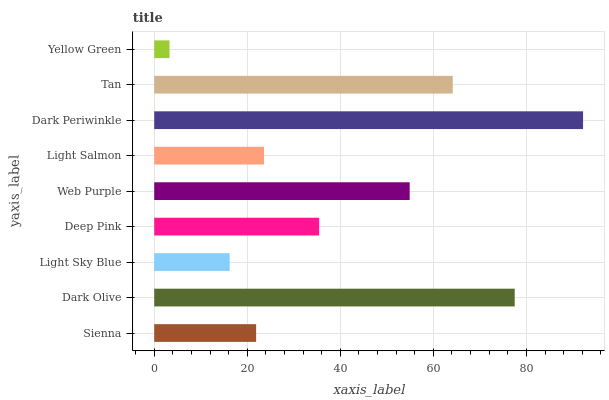Is Yellow Green the minimum?
Answer yes or no. Yes. Is Dark Periwinkle the maximum?
Answer yes or no. Yes. Is Dark Olive the minimum?
Answer yes or no. No. Is Dark Olive the maximum?
Answer yes or no. No. Is Dark Olive greater than Sienna?
Answer yes or no. Yes. Is Sienna less than Dark Olive?
Answer yes or no. Yes. Is Sienna greater than Dark Olive?
Answer yes or no. No. Is Dark Olive less than Sienna?
Answer yes or no. No. Is Deep Pink the high median?
Answer yes or no. Yes. Is Deep Pink the low median?
Answer yes or no. Yes. Is Dark Periwinkle the high median?
Answer yes or no. No. Is Dark Periwinkle the low median?
Answer yes or no. No. 